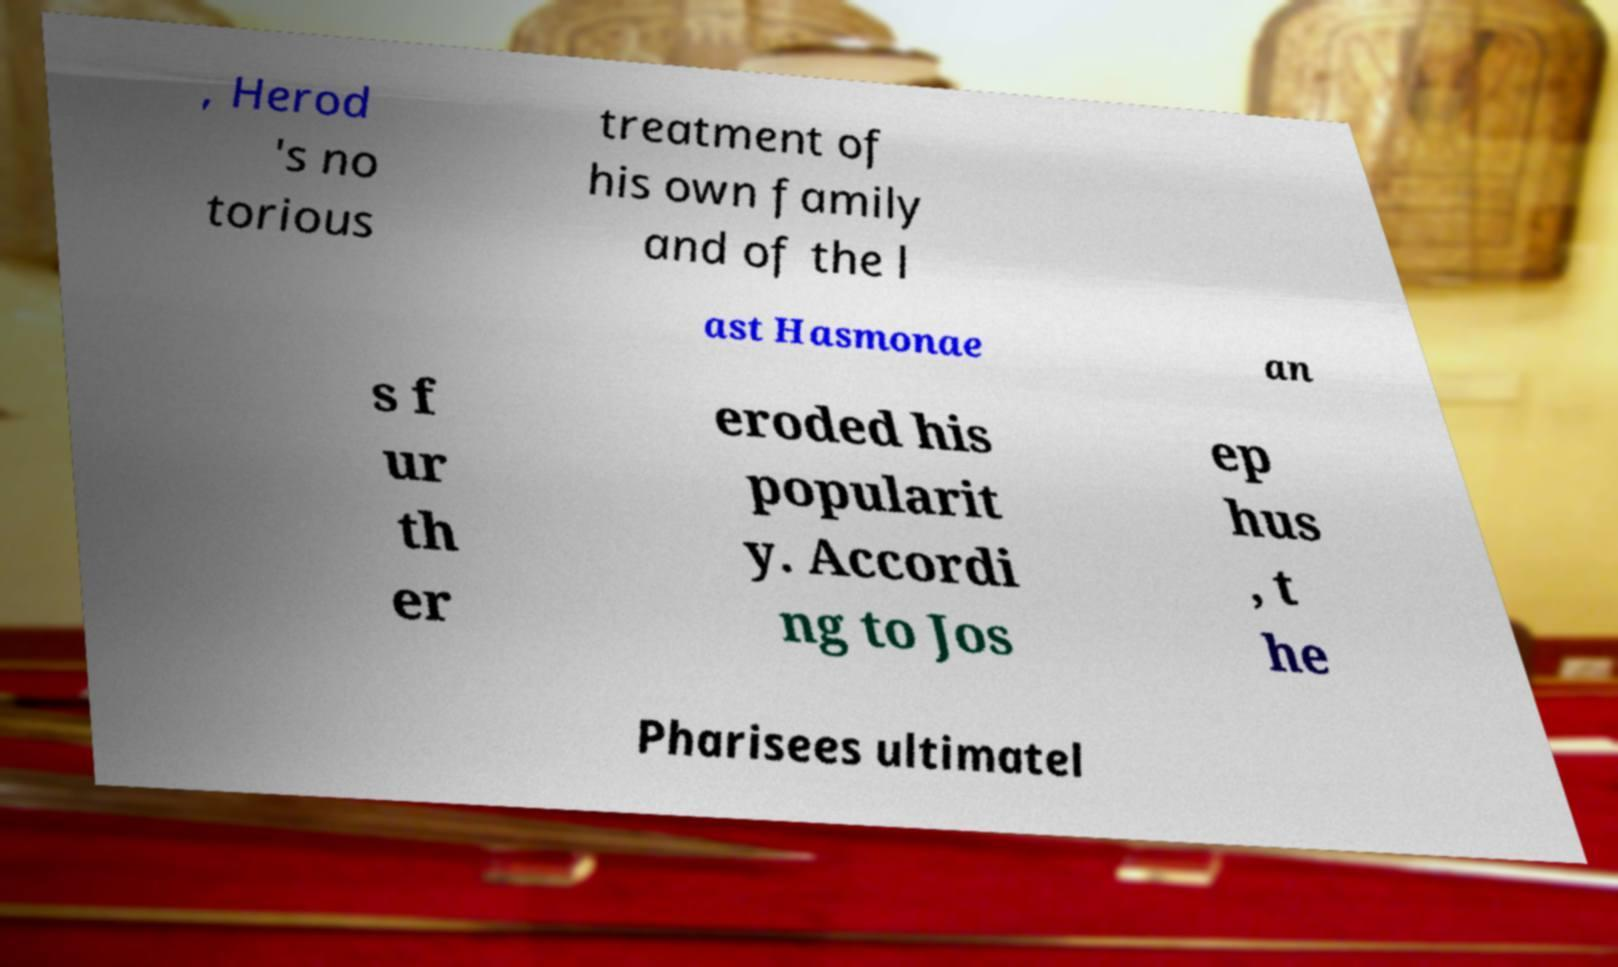What messages or text are displayed in this image? I need them in a readable, typed format. , Herod 's no torious treatment of his own family and of the l ast Hasmonae an s f ur th er eroded his popularit y. Accordi ng to Jos ep hus , t he Pharisees ultimatel 